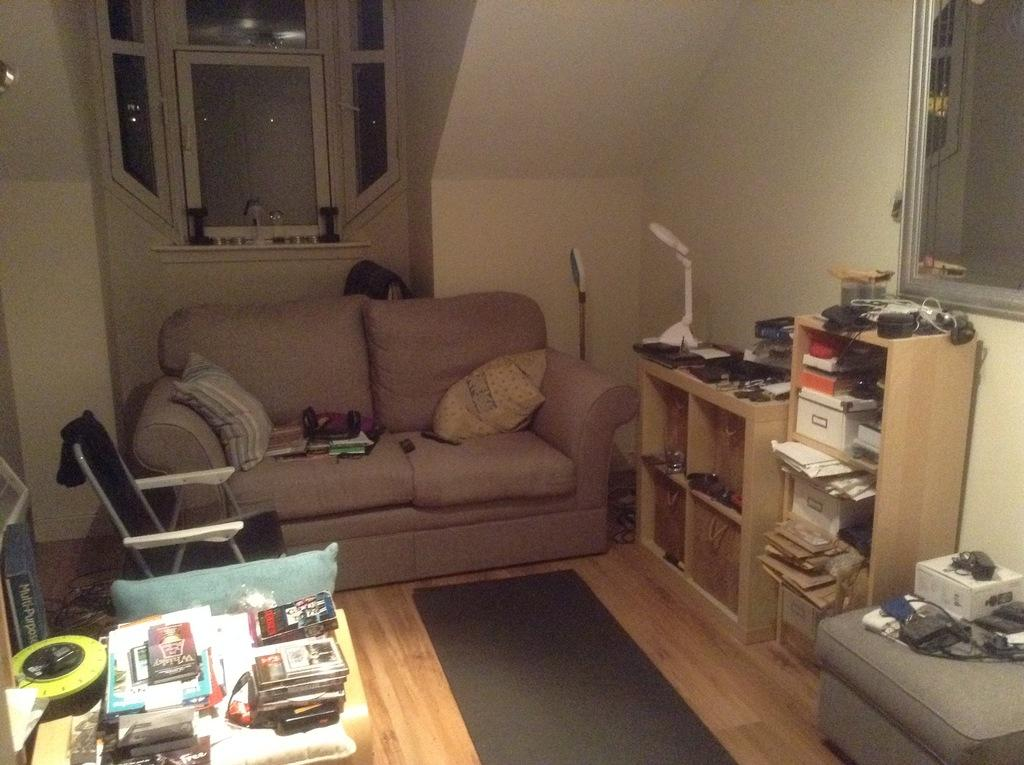What type of space is depicted in the image? The image shows an inside view of a room. What furniture is present in the room? There is a sofa in the room. What other item can be seen in the room? There is a rack in the room. What can be found on the table in the room? There are books on a table in the room. What architectural feature is visible in the room? There is a wall visible in the room. What type of paste is being used to connect the books on the table? There is no paste visible in the image, and the books are not being connected; they are simply placed on the table. 